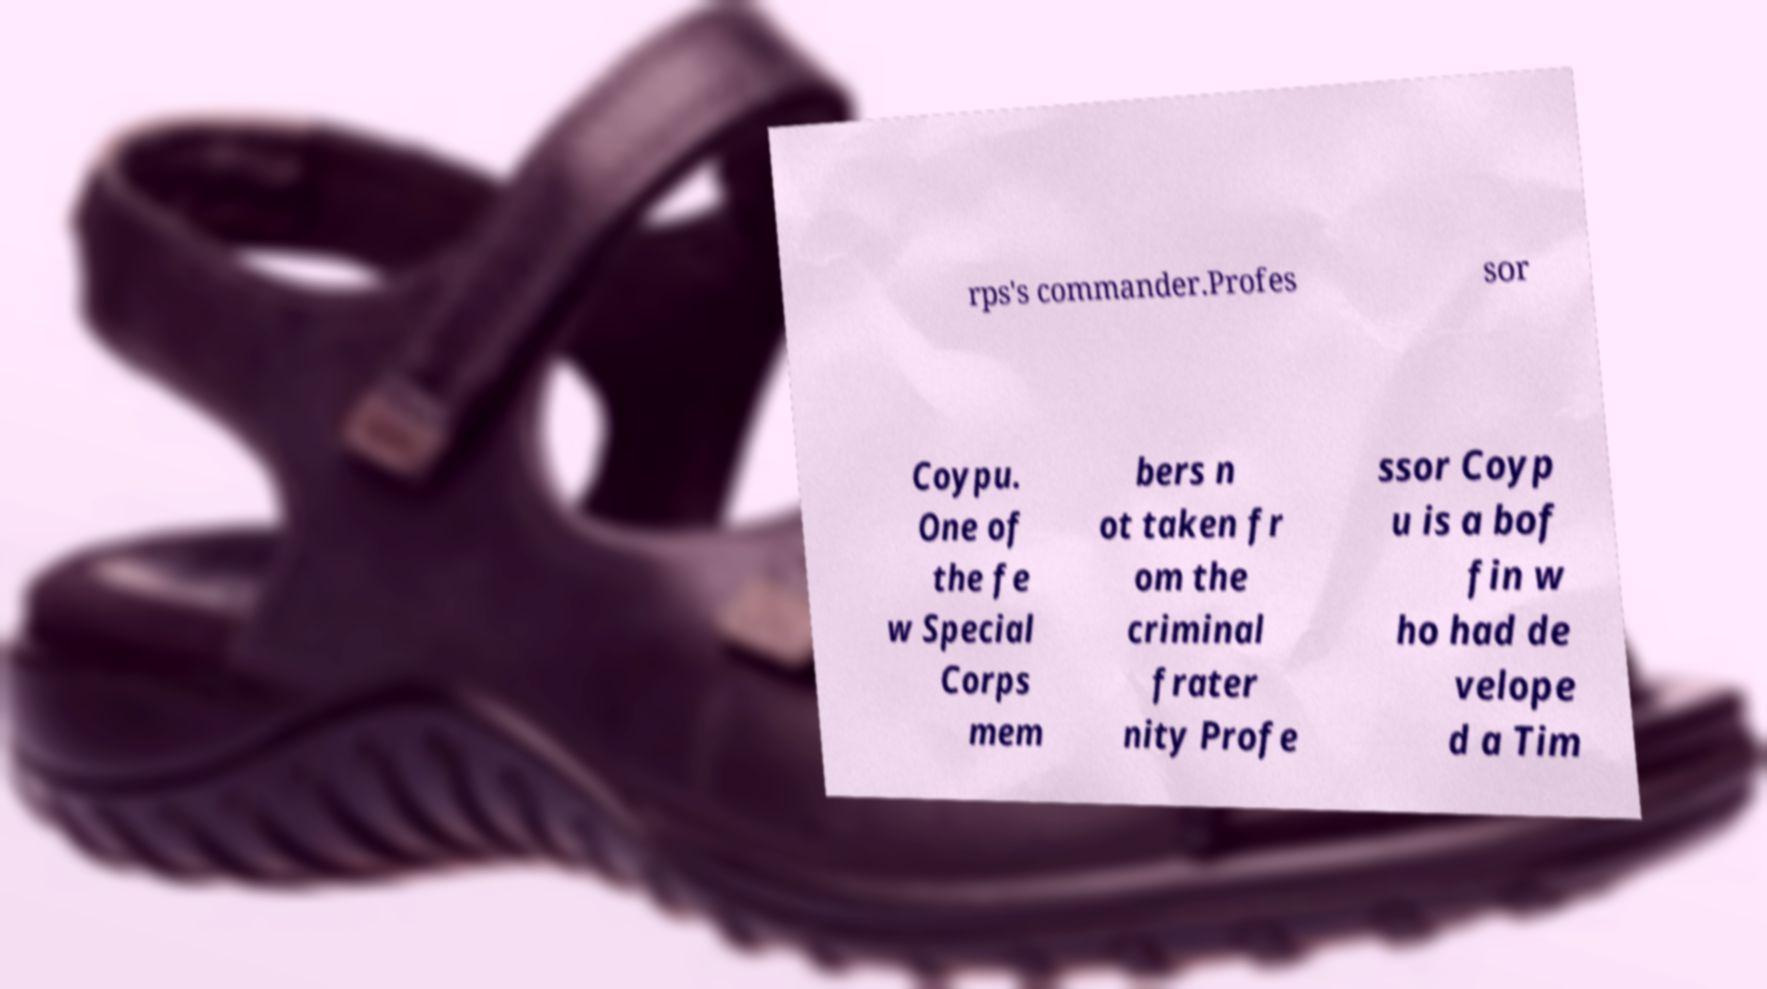Could you extract and type out the text from this image? rps's commander.Profes sor Coypu. One of the fe w Special Corps mem bers n ot taken fr om the criminal frater nity Profe ssor Coyp u is a bof fin w ho had de velope d a Tim 